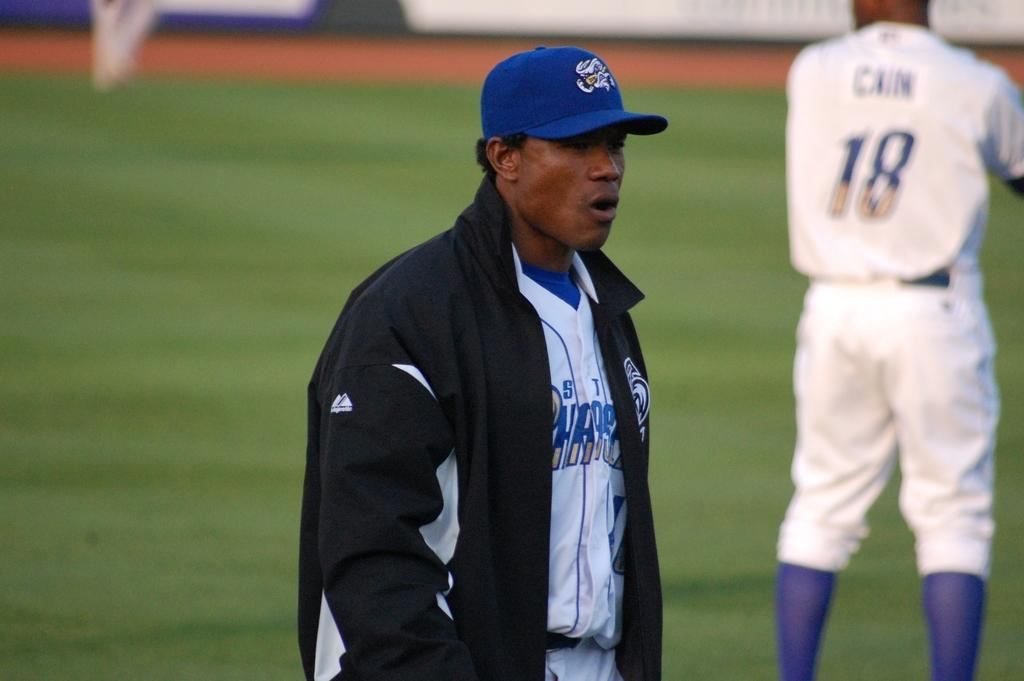<image>
Describe the image concisely. A baseball player wearing a jacket walks behind number 18 called cain who looks ready to play. 